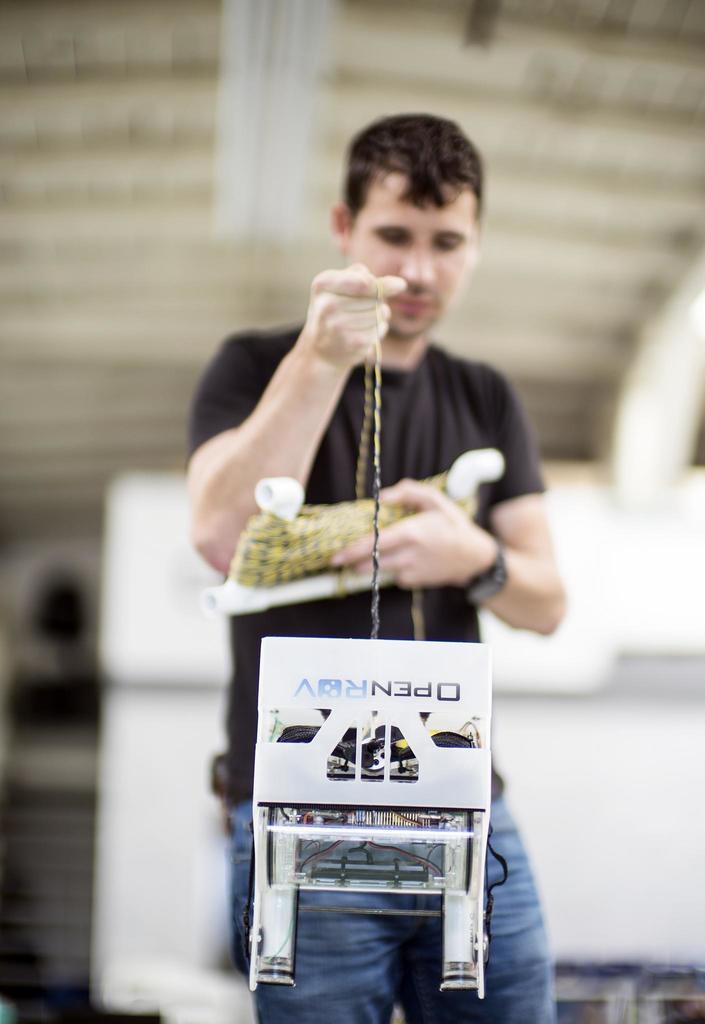Describe this image in one or two sentences. This image consists of a man wearing black T-shirt and blue jeans. In the background, there is a wall. He is holding a rope. 